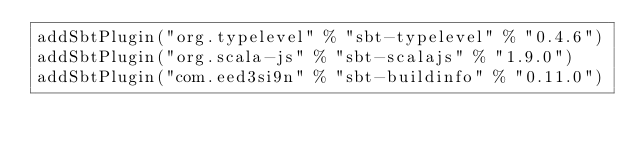Convert code to text. <code><loc_0><loc_0><loc_500><loc_500><_Scala_>addSbtPlugin("org.typelevel" % "sbt-typelevel" % "0.4.6")
addSbtPlugin("org.scala-js" % "sbt-scalajs" % "1.9.0")
addSbtPlugin("com.eed3si9n" % "sbt-buildinfo" % "0.11.0")
</code> 